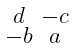Convert formula to latex. <formula><loc_0><loc_0><loc_500><loc_500>\begin{smallmatrix} d & - c \\ - b & a \end{smallmatrix}</formula> 